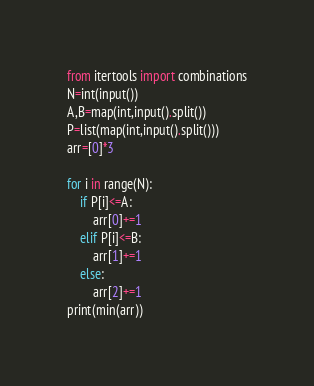<code> <loc_0><loc_0><loc_500><loc_500><_Python_>from itertools import combinations
N=int(input())
A,B=map(int,input().split())
P=list(map(int,input().split()))
arr=[0]*3

for i in range(N):
    if P[i]<=A:
        arr[0]+=1
    elif P[i]<=B:
        arr[1]+=1
    else:
        arr[2]+=1
print(min(arr))</code> 